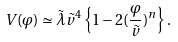<formula> <loc_0><loc_0><loc_500><loc_500>V ( \varphi ) \simeq \tilde { \lambda } \tilde { v } ^ { 4 } \left \{ 1 - 2 ( \frac { \varphi } { \tilde { v } } ) ^ { n } \right \} .</formula> 